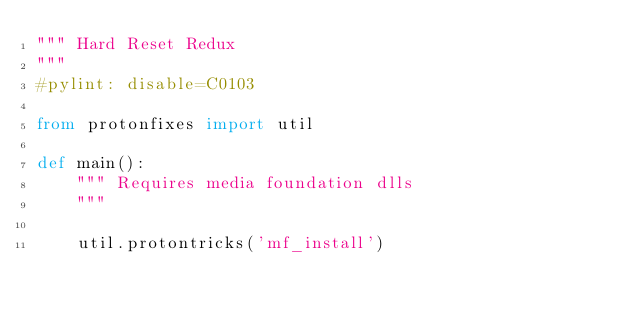Convert code to text. <code><loc_0><loc_0><loc_500><loc_500><_Python_>""" Hard Reset Redux
"""
#pylint: disable=C0103

from protonfixes import util

def main():
    """ Requires media foundation dlls
    """

    util.protontricks('mf_install')
 
</code> 